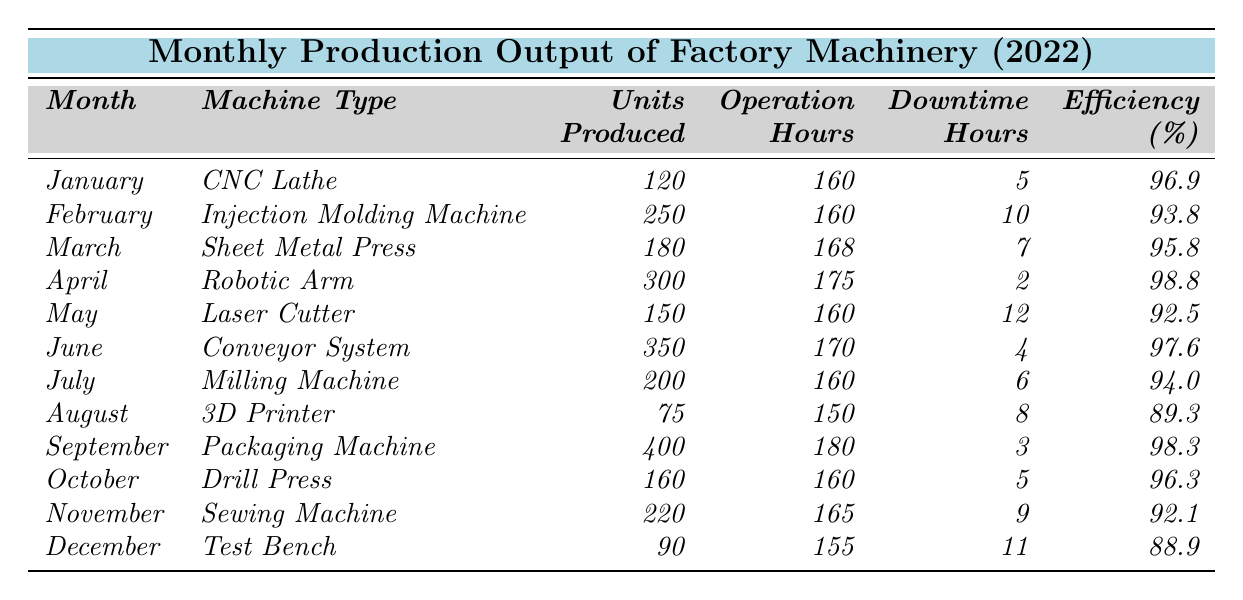What was the highest production output in a month? Looking at the "Units Produced" column, the highest value is 400 units in September for the Packaging Machine.
Answer: 400 Which machine had the lowest efficiency percentage? By checking the "Efficiency Percentage" column, the lowest value is 88.9% for the Test Bench in December.
Answer: 88.9 How many total units were produced from all machines in 2022? To find the total units produced, add up all the units from each month: 120 + 250 + 180 + 300 + 150 + 350 + 200 + 75 + 400 + 160 + 220 + 90 = 2,405.
Answer: 2405 Was the efficiency of the Robotic Arm in April higher than that of the Injection Molding Machine in February? The efficiency for the Robotic Arm is 98.8%, while the Injection Molding Machine has 93.8%. Since 98.8% is greater than 93.8%, the statement is true.
Answer: Yes What is the average efficiency percentage for the year? Calculate the average by summing all efficiency values (96.9 + 93.8 + 95.8 + 98.8 + 92.5 + 97.6 + 94.0 + 89.3 + 98.3 + 96.3 + 92.1 + 88.9 = 1,152.4), then divide by 12 months: 1,152.4 / 12 = 96.03.
Answer: 96.03 In which month did the Conveyor System operate for the most hours? The "Operation Hours" for the Conveyor System is 170, and comparing it with all other months, no machine has operated more hours than this. Thus, June has the highest operation hours.
Answer: June How many hours of downtime did occur in total during the year? Add all Downtime Hours: 5 + 10 + 7 + 2 + 12 + 4 + 6 + 8 + 3 + 5 + 9 + 11 = 82.
Answer: 82 Which machine produced 75 units, and in which month? The 3D Printer produced 75 units in August, as indicated in the "Units Produced" column.
Answer: August Was the production output in March greater than that in May? March had a production output of 180 units, and May had 150 units. Since 180 is greater than 150, this statement is true.
Answer: Yes Which month had the best efficiency and what was that value? April had the best efficiency of 98.8% for the Robotic Arm, the value is found in the efficiency column.
Answer: 98.8 